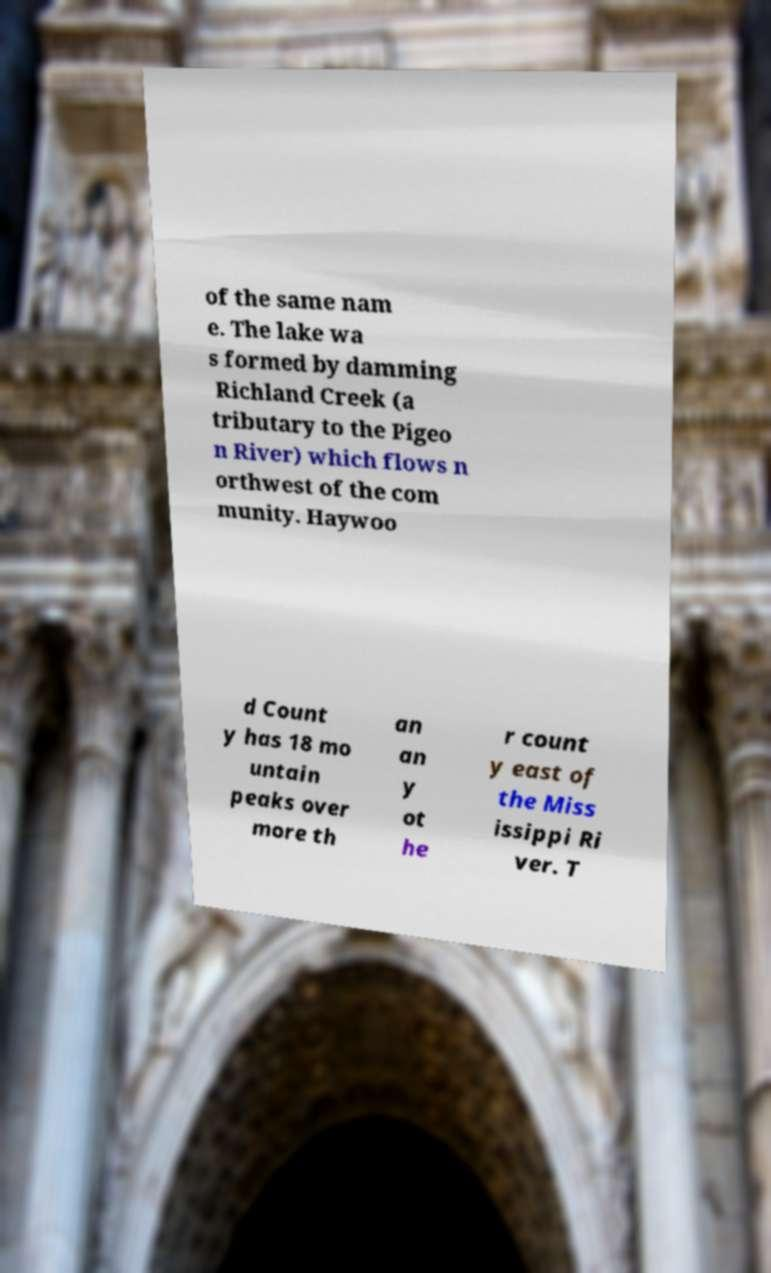Can you read and provide the text displayed in the image?This photo seems to have some interesting text. Can you extract and type it out for me? of the same nam e. The lake wa s formed by damming Richland Creek (a tributary to the Pigeo n River) which flows n orthwest of the com munity. Haywoo d Count y has 18 mo untain peaks over more th an an y ot he r count y east of the Miss issippi Ri ver. T 